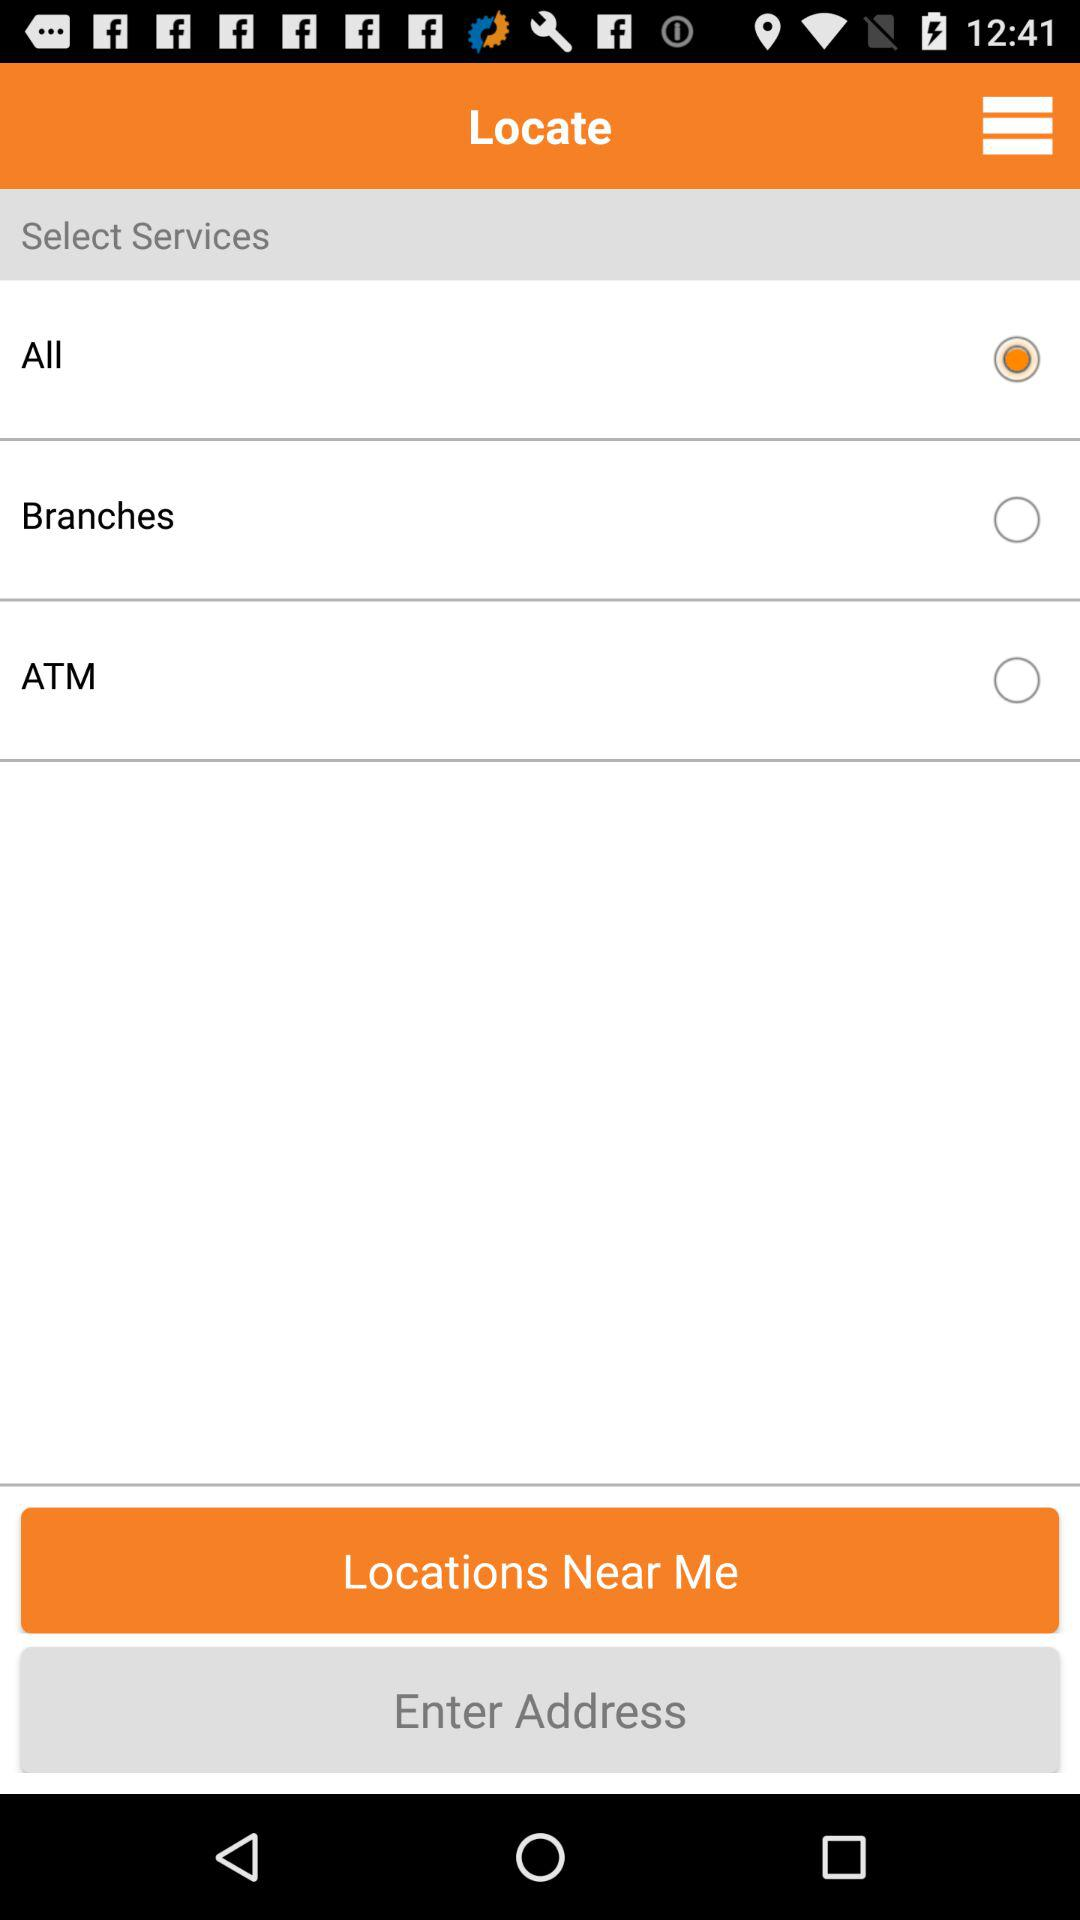What are the selected services? The selected service is "All". 